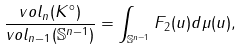<formula> <loc_0><loc_0><loc_500><loc_500>\frac { v o l _ { n } ( K ^ { \circ } ) } { v o l _ { n - 1 } ( \mathbb { S } ^ { n - 1 } ) } = \int _ { \mathbb { S } ^ { n - 1 } } F _ { 2 } ( u ) d \mu ( u ) ,</formula> 